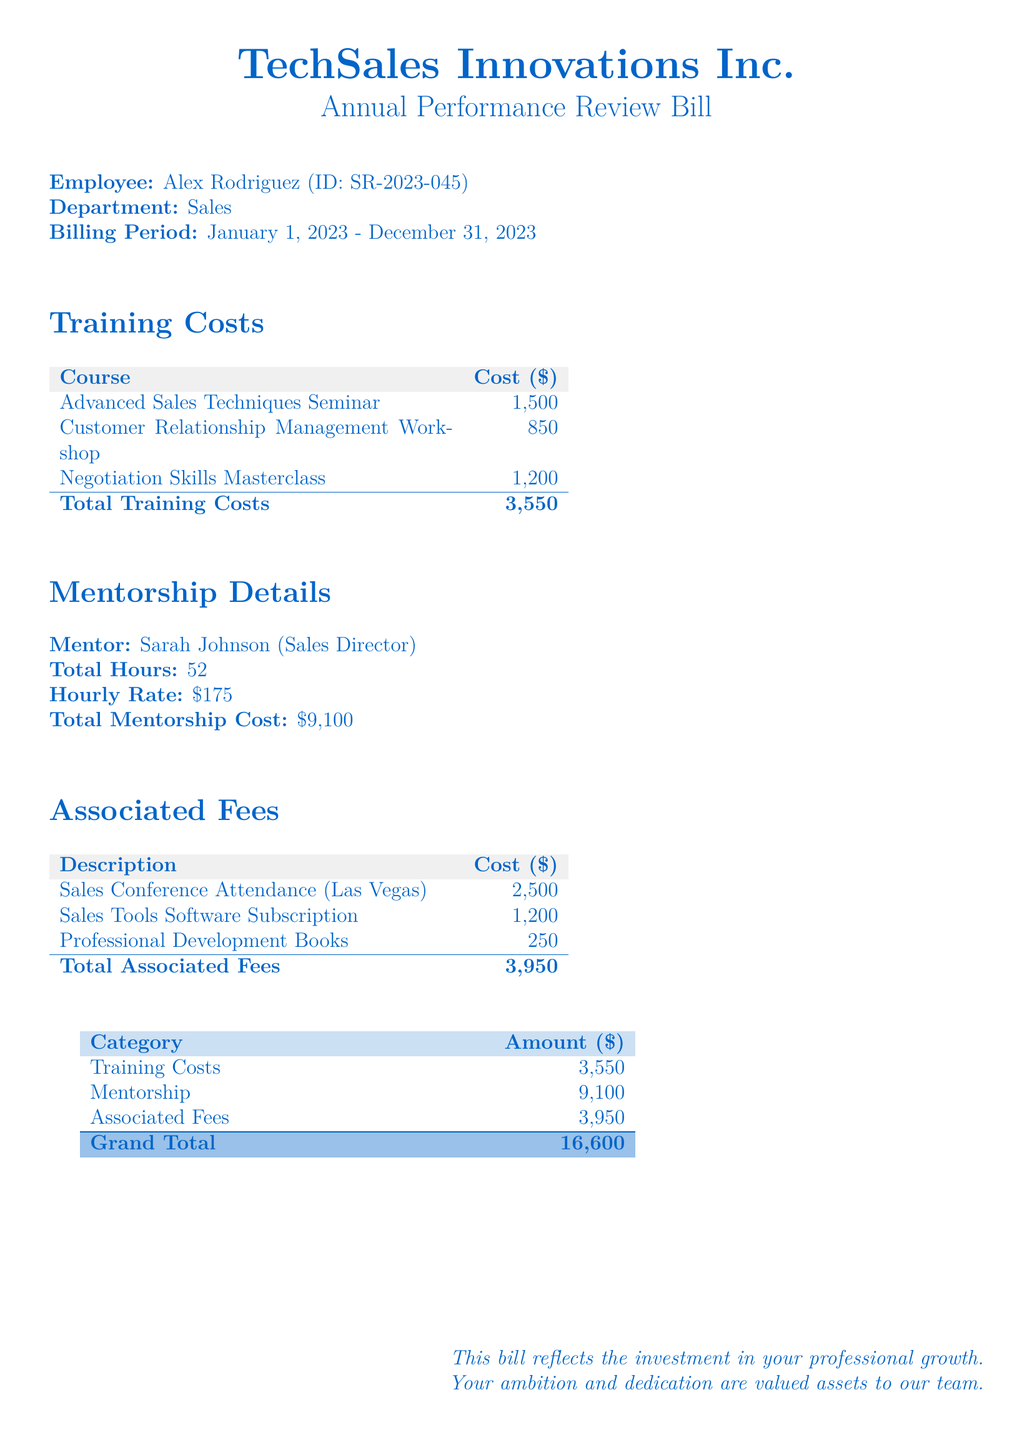What is the billing period? The billing period is indicated in the document as the timeframe for which the bill applies, from January 1, 2023 to December 31, 2023.
Answer: January 1, 2023 - December 31, 2023 Who is the mentor? The document specifies the name of the mentor who provided guidance during the mentorship period.
Answer: Sarah Johnson What is the total training cost? The total training costs can be found as the sum of all individual training course costs listed in the training section.
Answer: 3,550 How many mentorship hours are recorded? The document states the total number of hours dedicated to mentorship as per the detail provided in the mentorship section.
Answer: 52 What is the cost of the Sales Conference Attendance? The bill lists the cost associated with attendance at the Sales Conference as one of the associated fees.
Answer: 2,500 What is the grand total of the bill? The grand total is provided at the end of the document after summing all categories outlined.
Answer: 16,600 What is the hourly rate for mentorship? The document provides the rate for mentorship per hour as mentioned in the mentorship details.
Answer: 175 What is included in the associated fees? This question asks for information regarding the specific expenses categorized under associated fees in the document.
Answer: Sales Conference Attendance, Sales Tools Software Subscription, Professional Development Books 